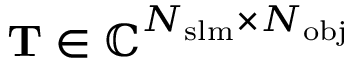Convert formula to latex. <formula><loc_0><loc_0><loc_500><loc_500>T \in \mathbb { C } ^ { N _ { s l m } \times N _ { o b j } }</formula> 